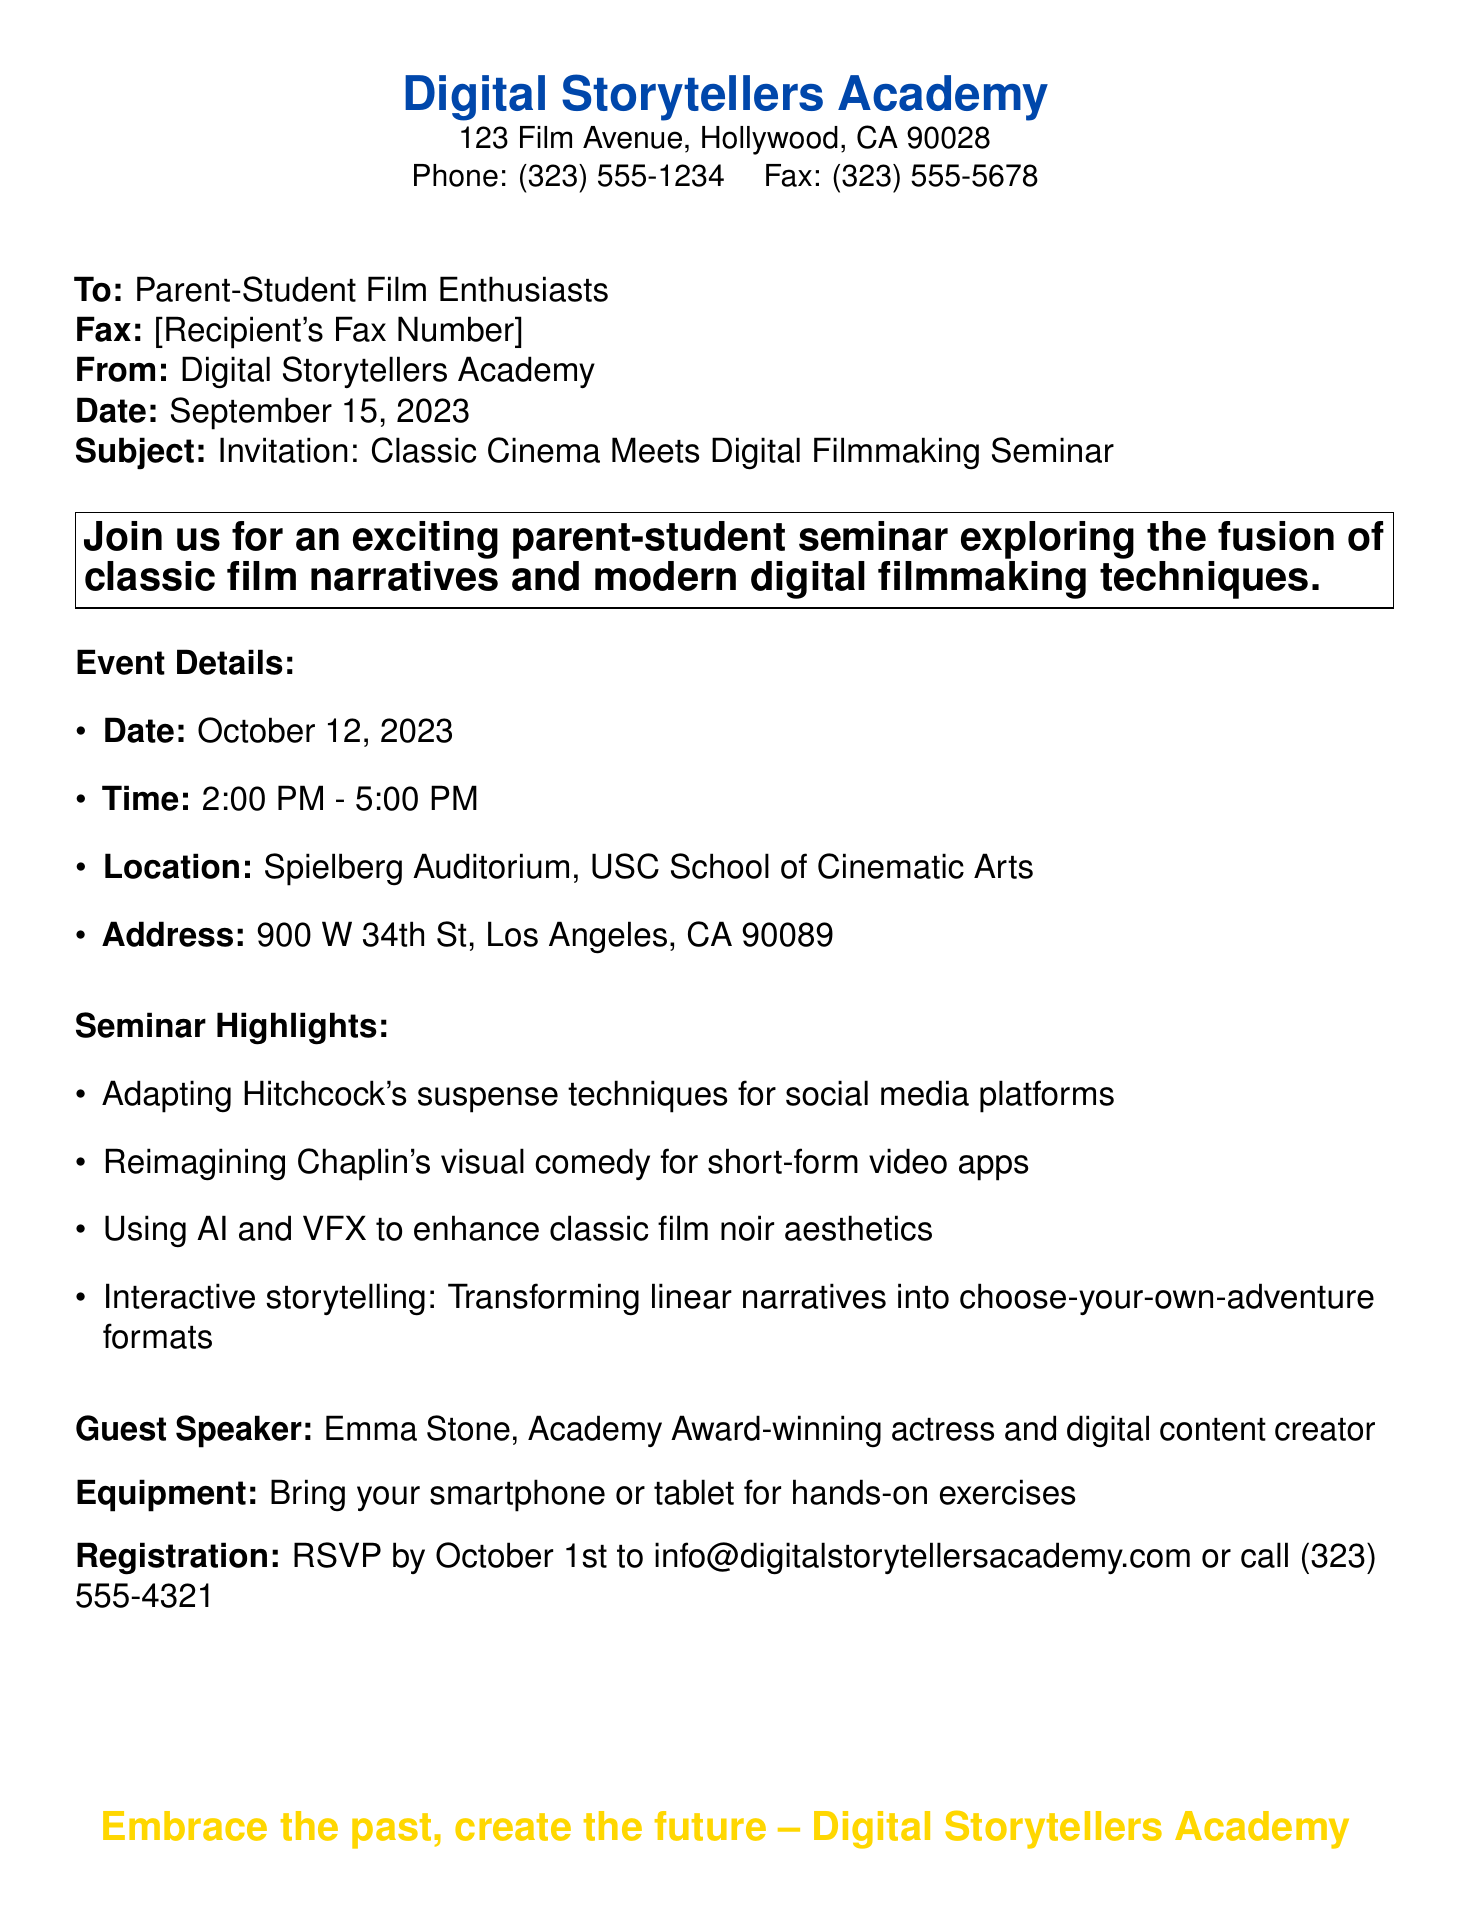What is the date of the seminar? The date of the seminar is explicitly stated in the document.
Answer: October 12, 2023 Who is the guest speaker? The document identifies the guest speaker as an Academy Award-winning actress.
Answer: Emma Stone What time does the seminar start? The document provides the specific time for the seminar.
Answer: 2:00 PM What location will the seminar be held? The seminar's location is clearly noted in the document.
Answer: Spielberg Auditorium, USC School of Cinematic Arts What equipment should participants bring? The document mentions what participants need to bring for hands-on exercises.
Answer: Smartphone or tablet When is the RSVP deadline? The document specifies the last date to register for the seminar.
Answer: October 1st How long is the seminar? The document states the duration of the seminar through its start and end times.
Answer: 3 hours What are two highlights of the seminar? The invitation lists seminar highlights that cover different aspects.
Answer: Adapting Hitchcock's suspense techniques, Reimagining Chaplin's visual comedy What is the fax number provided in the document? The fax number is mentioned for communication purposes and can be found in the header.
Answer: (323) 555-5678 